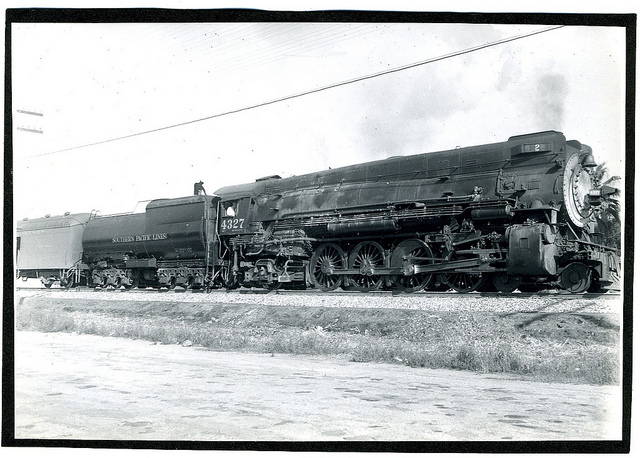How many train cars have yellow on them? After carefully examining the image, it appears that there are no train cars with yellow coloring visible. The photograph is black and white, making it difficult to determine the original colors. However, no shades of yellow are discernible in this monochromatic image. 